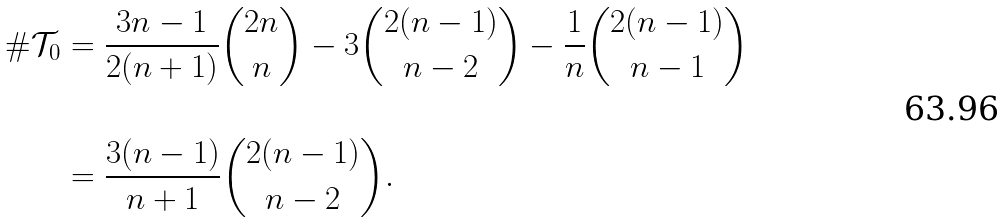Convert formula to latex. <formula><loc_0><loc_0><loc_500><loc_500>\# \mathcal { T } _ { 0 } & = \frac { 3 n - 1 } { 2 ( n + 1 ) } { 2 n \choose n } - 3 { 2 ( n - 1 ) \choose n - 2 } - \frac { 1 } { n } { 2 ( n - 1 ) \choose n - 1 } \\ \\ & = \frac { 3 ( n - 1 ) } { n + 1 } { 2 ( n - 1 ) \choose n - 2 } . \\</formula> 